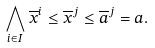Convert formula to latex. <formula><loc_0><loc_0><loc_500><loc_500>\bigwedge _ { i \in I } \overline { x } ^ { i } \leq \overline { x } ^ { j } \leq \overline { a } ^ { j } = a .</formula> 